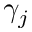<formula> <loc_0><loc_0><loc_500><loc_500>\gamma _ { j }</formula> 